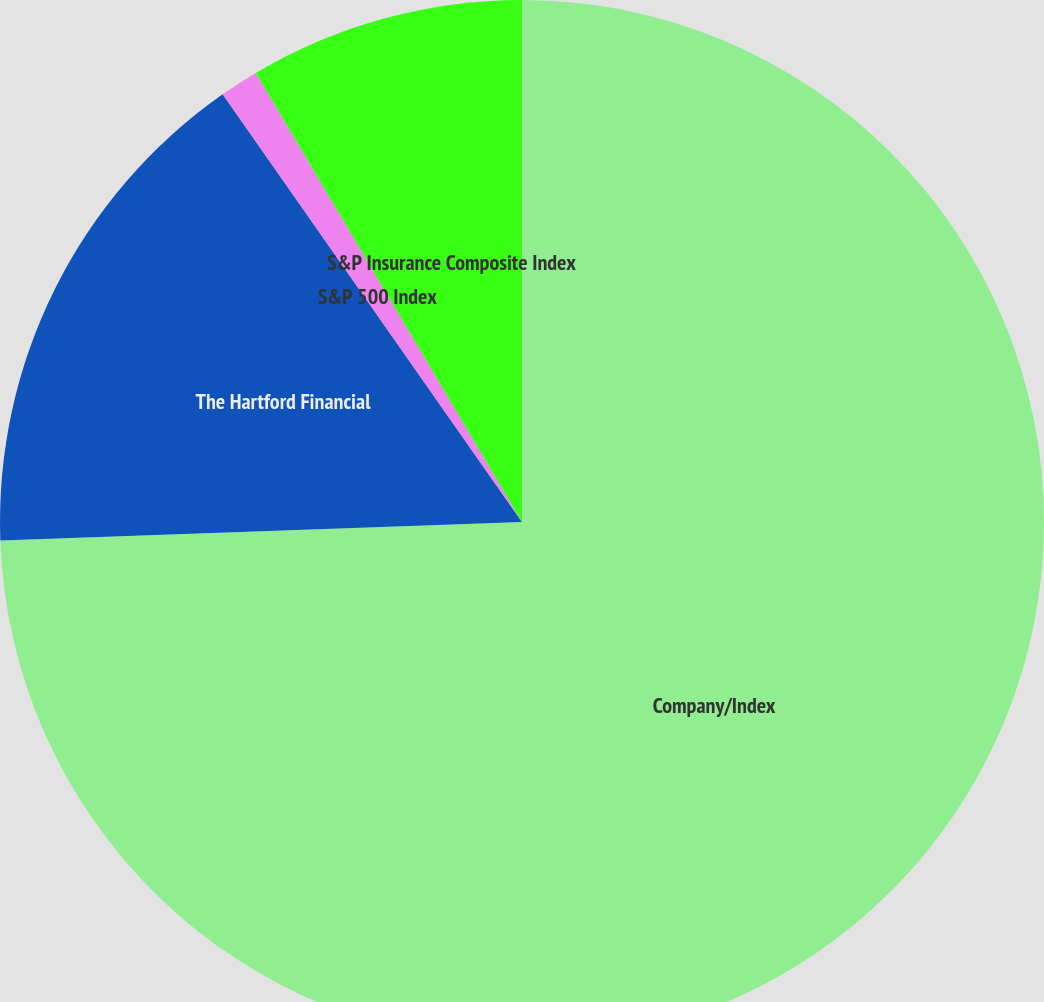Convert chart to OTSL. <chart><loc_0><loc_0><loc_500><loc_500><pie_chart><fcel>Company/Index<fcel>The Hartford Financial<fcel>S&P 500 Index<fcel>S&P Insurance Composite Index<nl><fcel>74.44%<fcel>15.85%<fcel>1.2%<fcel>8.52%<nl></chart> 